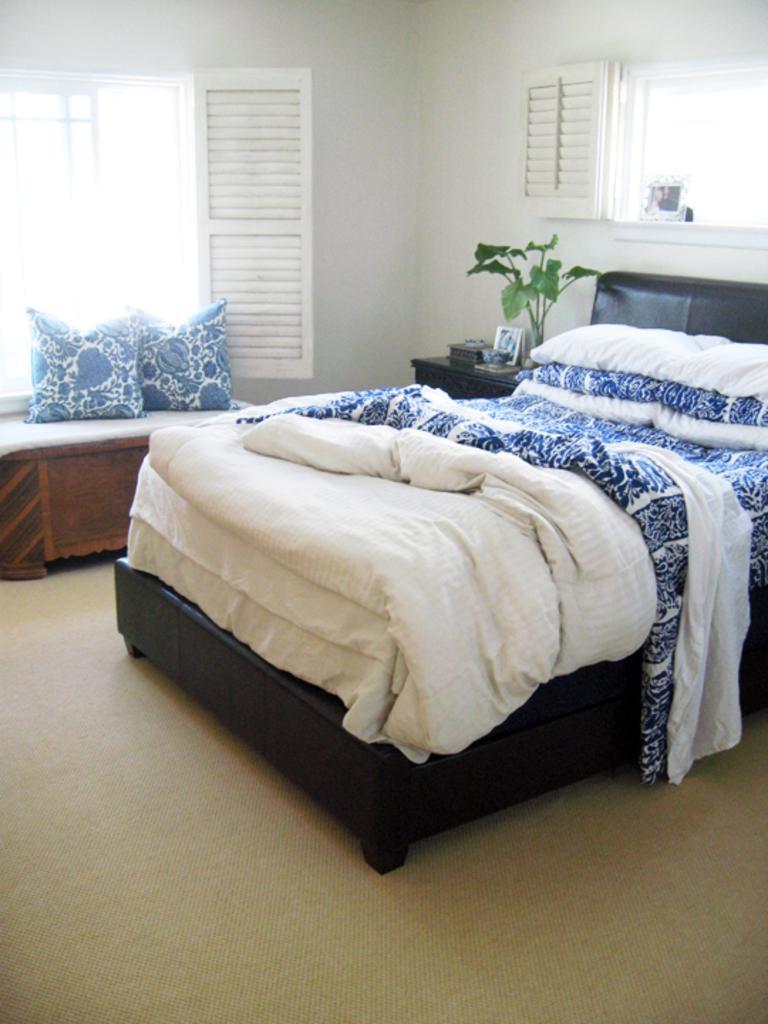Please provide a concise description of this image. In this room there is bed,house plant,window and a wall. There are pillows here on the left. 